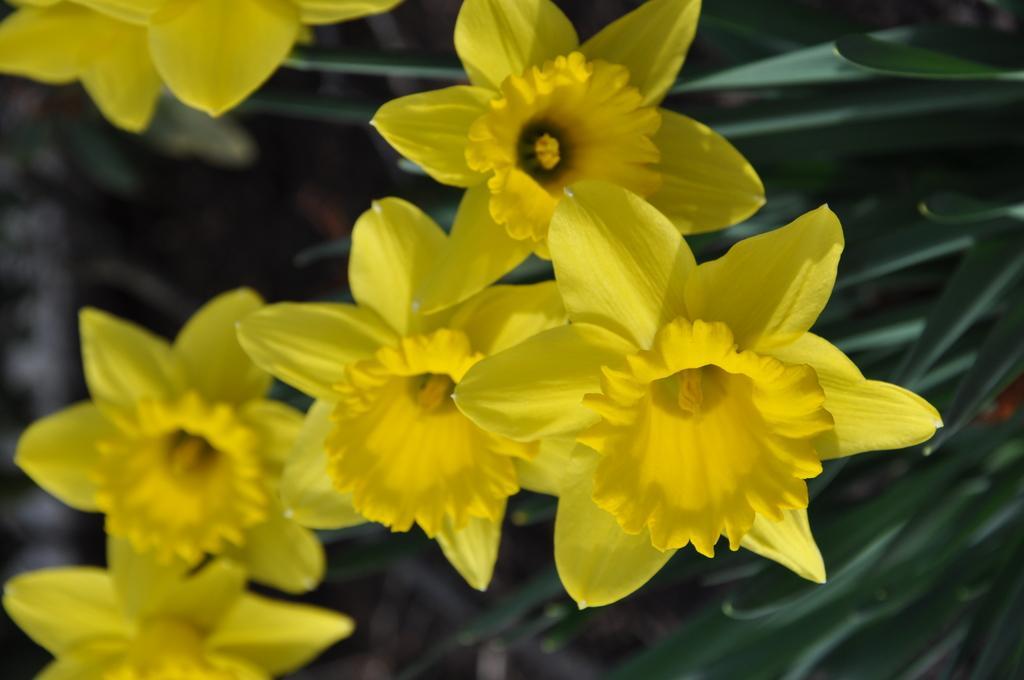In one or two sentences, can you explain what this image depicts? There are plants having yellow color flowers and green color leaves and the background is blurred. 